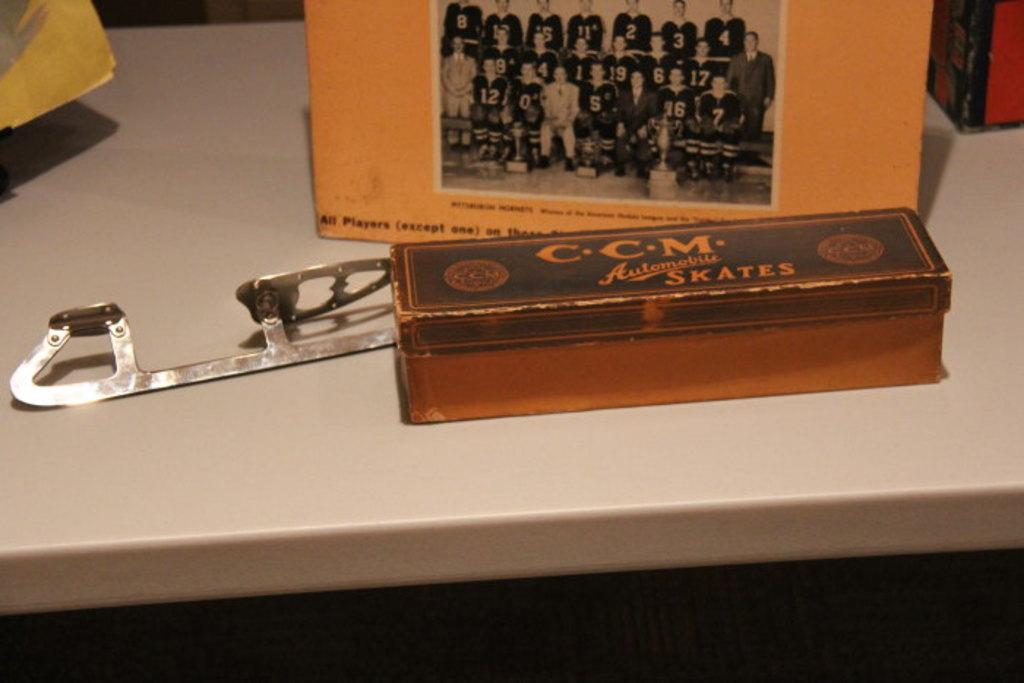<image>
Give a short and clear explanation of the subsequent image. An old team photo framed behind a box that says C.C.M 